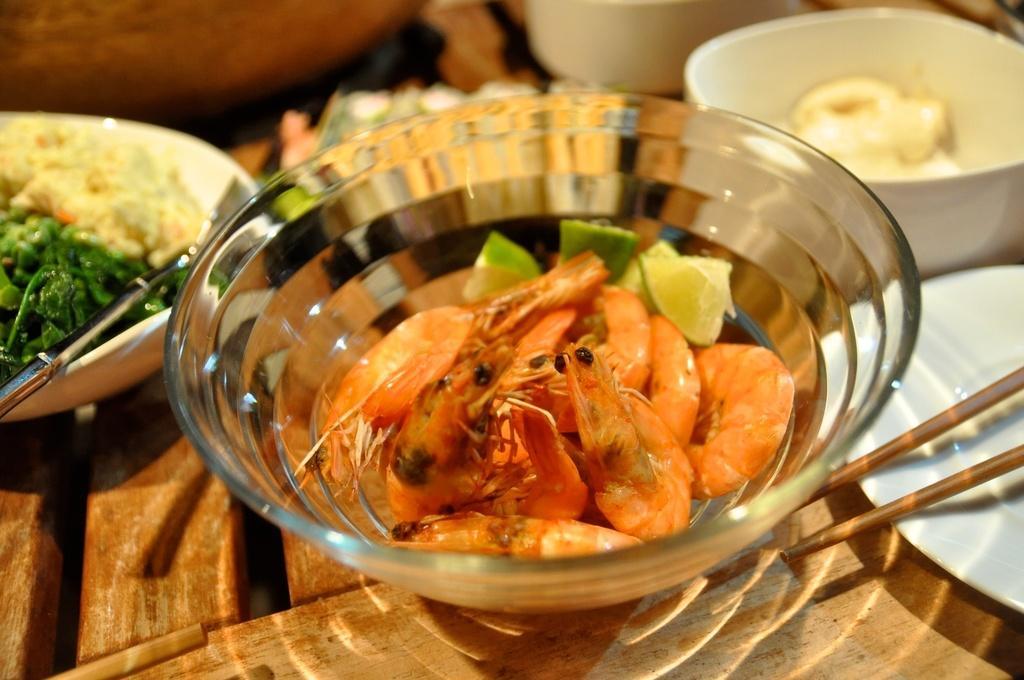Can you describe this image briefly? In this image we can see a group of bowls containing food in them and spoons. To the right side of the image we can see chopsticks. 